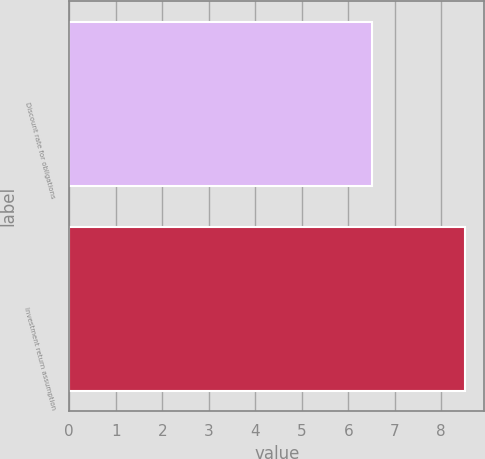Convert chart. <chart><loc_0><loc_0><loc_500><loc_500><bar_chart><fcel>Discount rate for obligations<fcel>Investment return assumption<nl><fcel>6.5<fcel>8.5<nl></chart> 